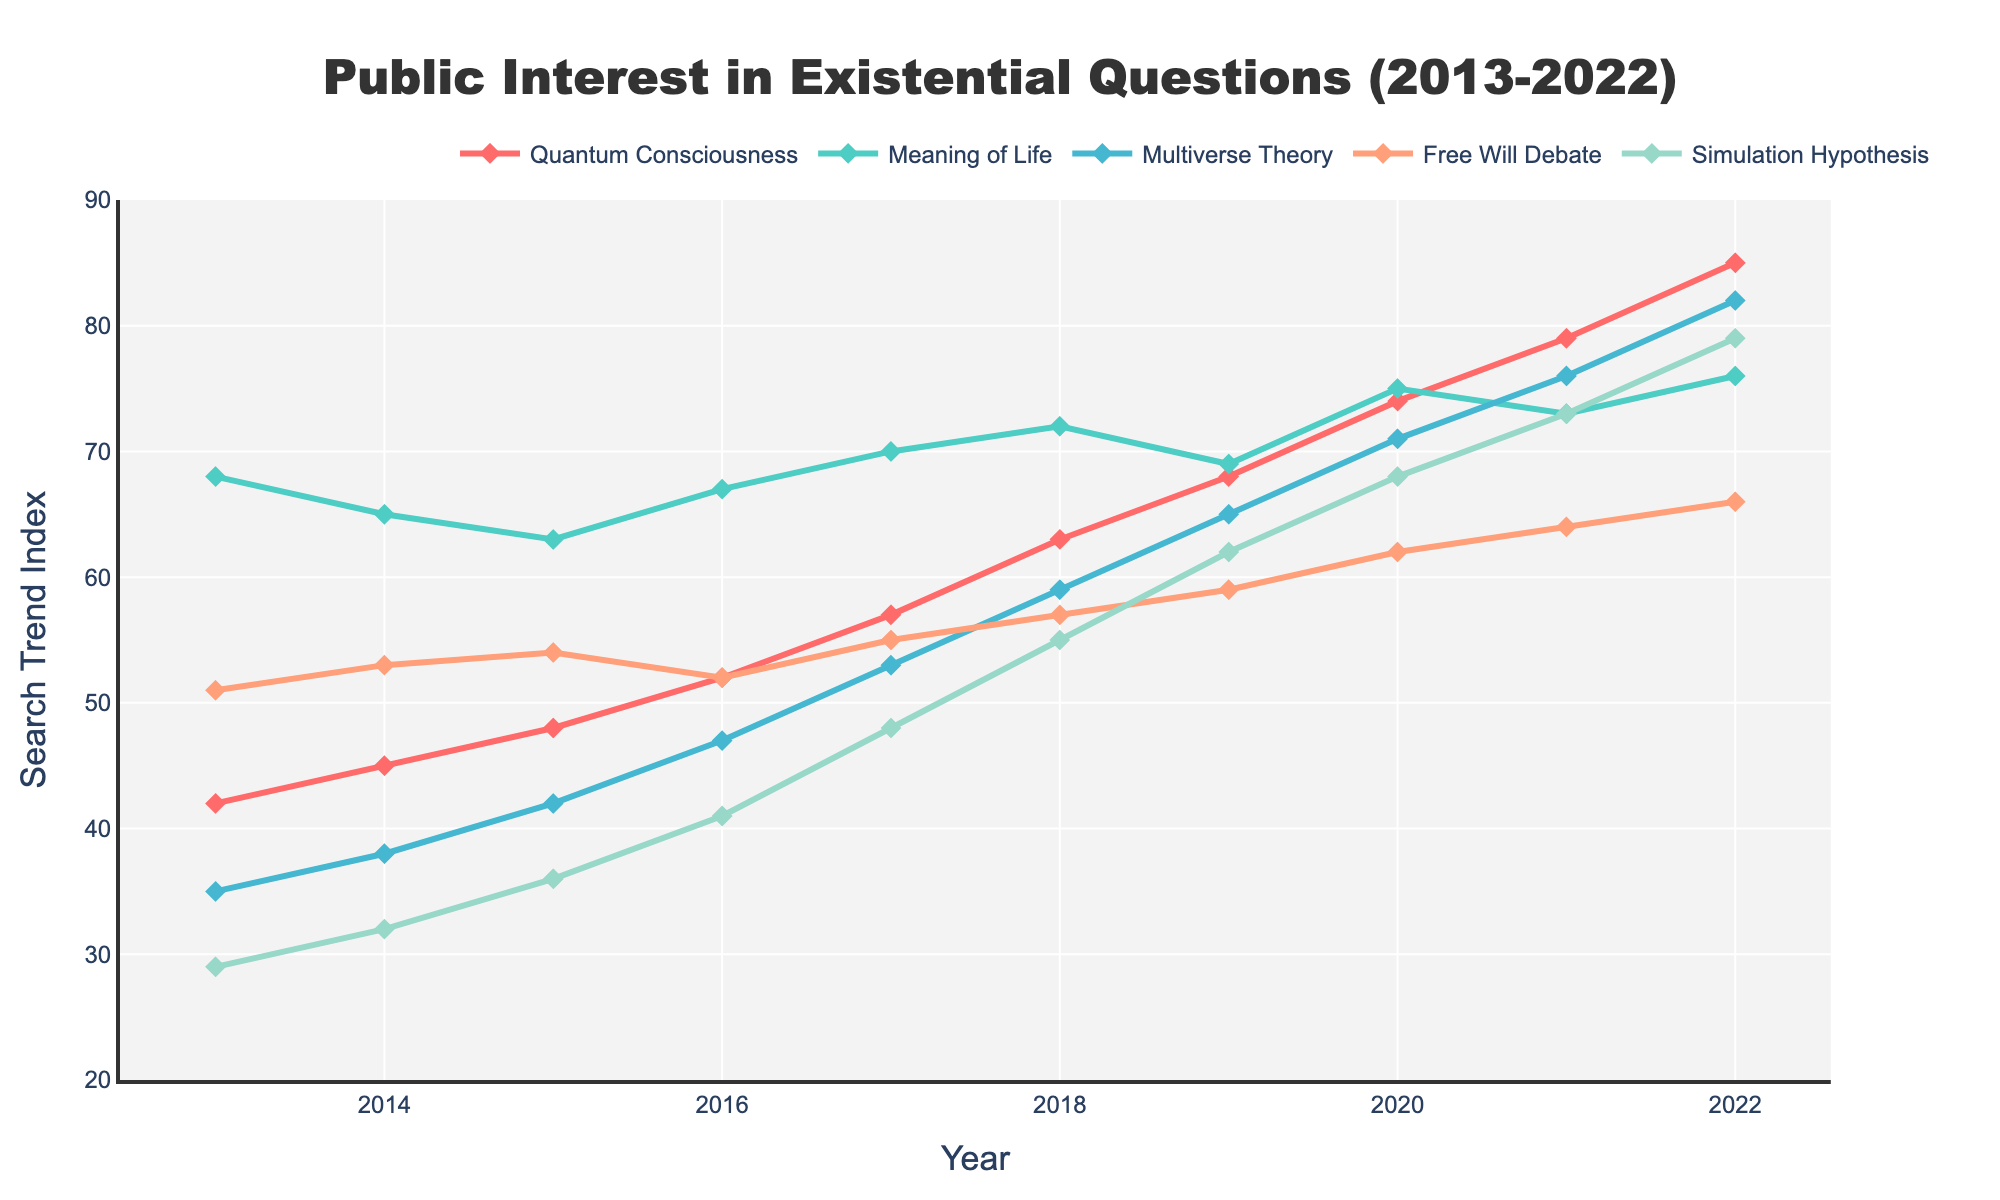Which existential topic experienced the highest growth in public interest between 2013 and 2022? To find the highest growth, we calculate the difference between 2022 and 2013 for each topic. For "Quantum Consciousness": 85 - 42 = 43, "Meaning of Life": 76 - 68 = 8, "Multiverse Theory": 82 - 35 = 47, "Free Will Debate": 66 - 51 = 15, and "Simulation Hypothesis": 79 - 29 = 50. The "Simulation Hypothesis" has the highest growth of 50.
Answer: Simulation Hypothesis Which year had the highest overall public interest in the "Meaning of Life"? We examine the "Meaning of Life" line on the chart and identify the highest point. In 2020, the index value for "Meaning of Life" is 75, which is the peak value.
Answer: 2020 What is the average public interest index for "Multiverse Theory" across the decade? Sum the annual values for "Multiverse Theory": 35 + 38 + 42 + 47 + 53 + 59 + 65 + 71 + 76 + 82 = 568, then divide by the number of years (10). The average is 568 / 10 = 56.8.
Answer: 56.8 Which topic had the least variation in public interest over the decade? The variation is determined by subtracting the minimum from the maximum value for each topic. After calculating, "Meaning of Life" (76 - 63 = 13) shows the least variation.
Answer: Meaning of Life In which year did public interest in "Quantum Consciousness" exceed "Free Will Debate" for the first time? By comparing the values for "Quantum Consciousness" and "Free Will Debate" year by year, in 2016, "Quantum Consciousness" (52) first exceeded "Free Will Debate" (51).
Answer: 2016 How many topics showed a continuous increase in public interest each year from 2013 to 2022? By examining each trend line, "Quantum Consciousness" and "Simulation Hypothesis" both show continuous increases every year.
Answer: 2 What is the sum of public interest indexes for "Free Will Debate" in 2019 and 2020? Add the values for 2019 (59) and 2020 (62). The sum is 59 + 62 = 121.
Answer: 121 